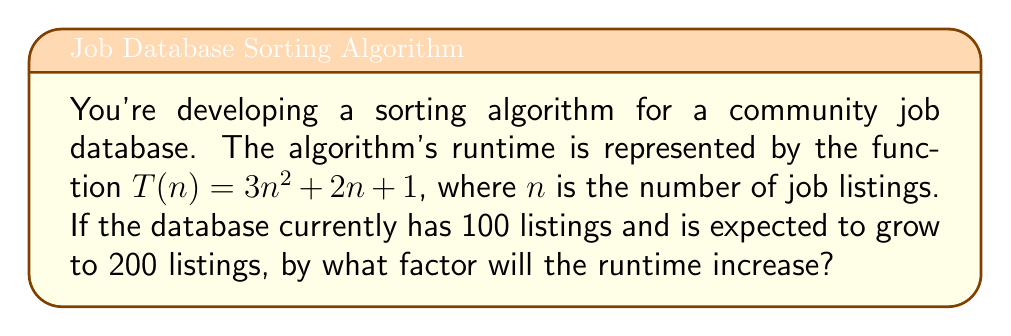Give your solution to this math problem. Let's approach this step-by-step:

1) First, we need to calculate the runtime for 100 listings:
   $T(100) = 3(100)^2 + 2(100) + 1$
   $= 30,000 + 200 + 1$
   $= 30,201$

2) Next, we calculate the runtime for 200 listings:
   $T(200) = 3(200)^2 + 2(200) + 1$
   $= 120,000 + 400 + 1$
   $= 120,401$

3) To find the factor by which the runtime increases, we divide the new runtime by the original runtime:

   $\frac{T(200)}{T(100)} = \frac{120,401}{30,201}$

4) Simplifying this fraction:
   $\frac{120,401}{30,201} \approx 3.9867$

This means the runtime increases by a factor of approximately 3.9867.

5) We can verify this result theoretically:
   For a quadratic function like $T(n) = 3n^2 + 2n + 1$, doubling the input should increase the runtime by a factor of about 4. This is because the dominant term $3n^2$ quadruples when $n$ doubles, while the lower-order terms have less impact as $n$ grows larger.

This analysis shows how the input size significantly impacts the algorithm's performance, especially for algorithms with higher-order polynomial runtimes.
Answer: The runtime will increase by a factor of approximately 3.9867. 